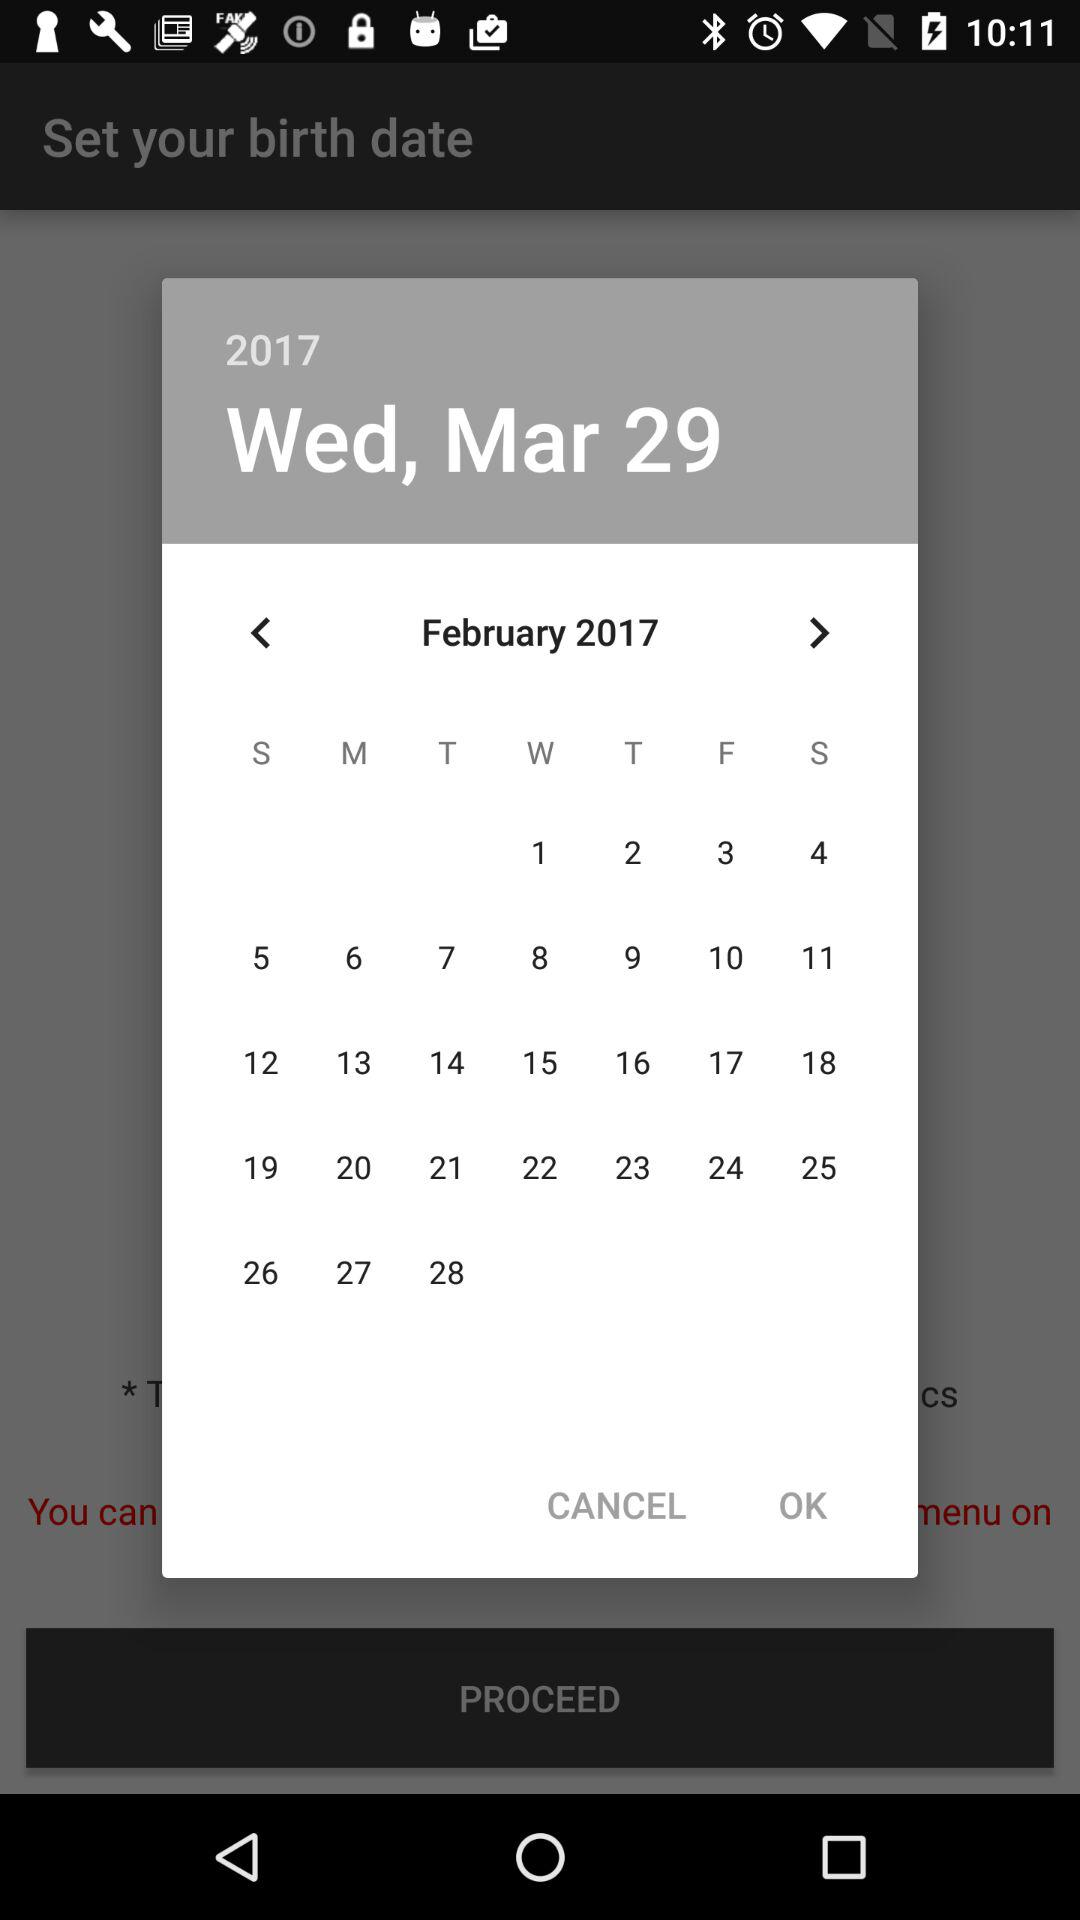What is the day on March 29, 2017? The day is Wednesday. 